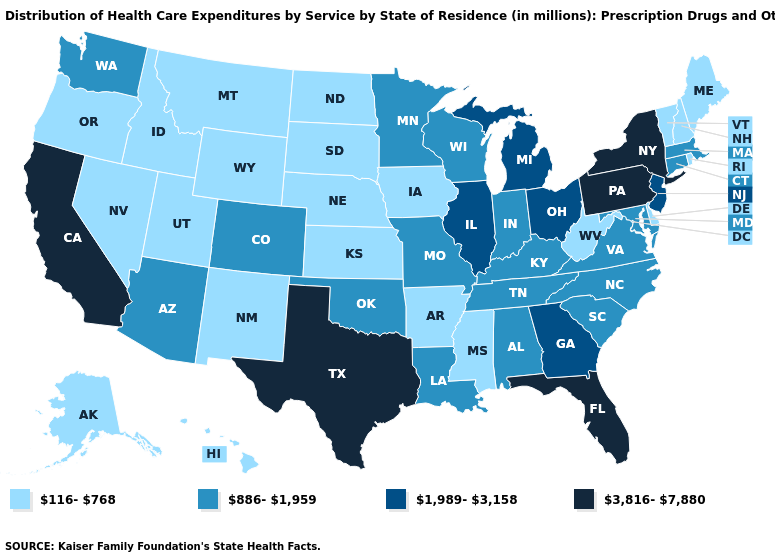Does the map have missing data?
Quick response, please. No. Does Florida have the highest value in the USA?
Quick response, please. Yes. Does Washington have the lowest value in the West?
Give a very brief answer. No. Name the states that have a value in the range 3,816-7,880?
Write a very short answer. California, Florida, New York, Pennsylvania, Texas. Name the states that have a value in the range 1,989-3,158?
Short answer required. Georgia, Illinois, Michigan, New Jersey, Ohio. Which states have the highest value in the USA?
Concise answer only. California, Florida, New York, Pennsylvania, Texas. Name the states that have a value in the range 3,816-7,880?
Give a very brief answer. California, Florida, New York, Pennsylvania, Texas. Which states hav the highest value in the West?
Quick response, please. California. Name the states that have a value in the range 3,816-7,880?
Quick response, please. California, Florida, New York, Pennsylvania, Texas. What is the value of Kentucky?
Keep it brief. 886-1,959. Does Montana have a lower value than Indiana?
Quick response, please. Yes. Is the legend a continuous bar?
Write a very short answer. No. Name the states that have a value in the range 116-768?
Concise answer only. Alaska, Arkansas, Delaware, Hawaii, Idaho, Iowa, Kansas, Maine, Mississippi, Montana, Nebraska, Nevada, New Hampshire, New Mexico, North Dakota, Oregon, Rhode Island, South Dakota, Utah, Vermont, West Virginia, Wyoming. Does Alaska have the lowest value in the West?
Concise answer only. Yes. Which states have the highest value in the USA?
Quick response, please. California, Florida, New York, Pennsylvania, Texas. 